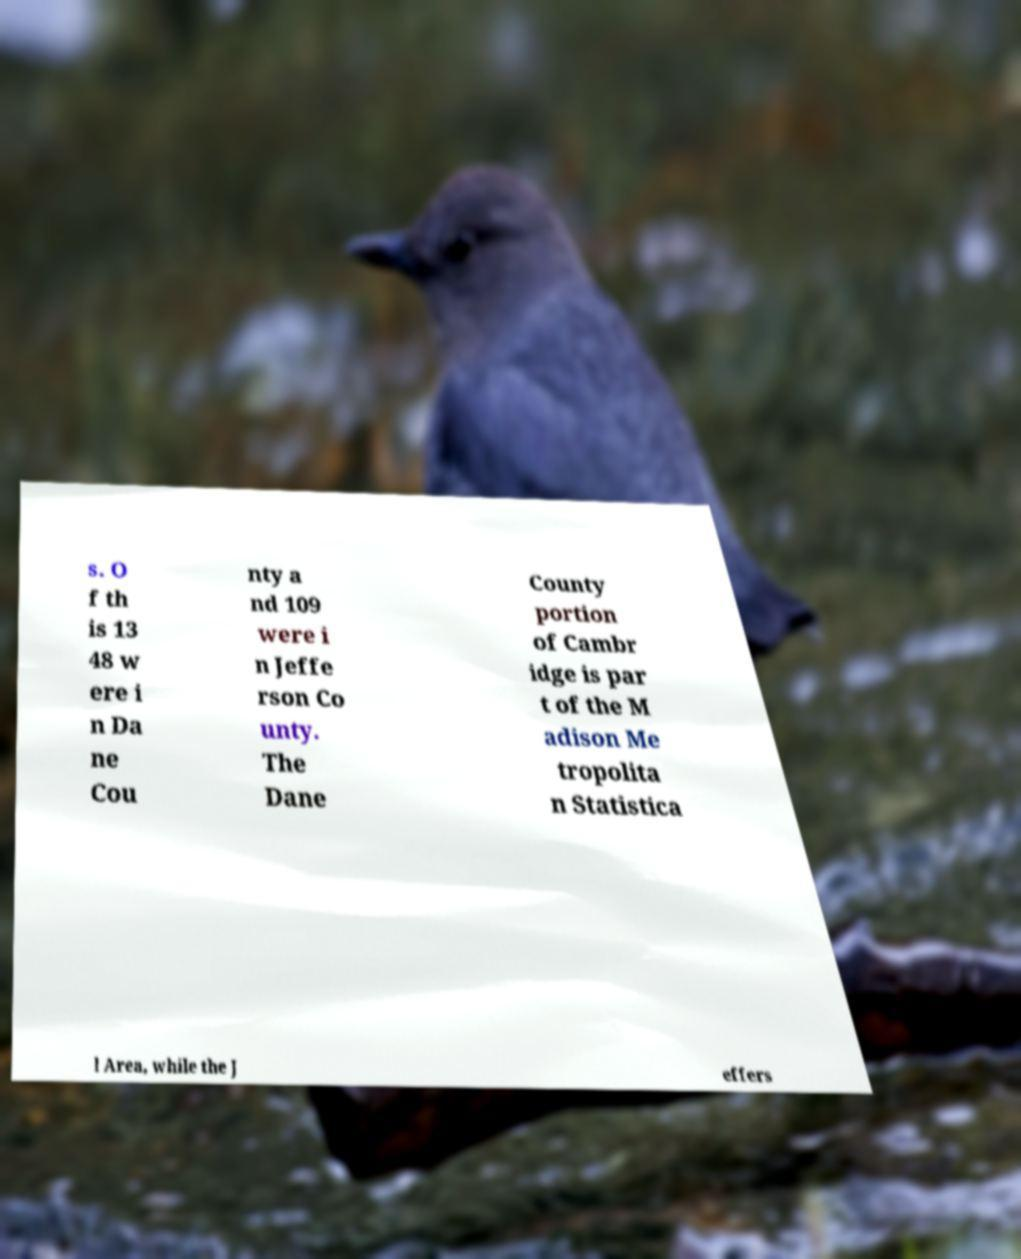For documentation purposes, I need the text within this image transcribed. Could you provide that? s. O f th is 13 48 w ere i n Da ne Cou nty a nd 109 were i n Jeffe rson Co unty. The Dane County portion of Cambr idge is par t of the M adison Me tropolita n Statistica l Area, while the J effers 